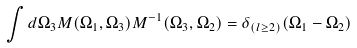Convert formula to latex. <formula><loc_0><loc_0><loc_500><loc_500>\int d \Omega _ { 3 } M ( \Omega _ { 1 } , \Omega _ { 3 } ) M ^ { - 1 } ( \Omega _ { 3 } , \Omega _ { 2 } ) = \delta _ { ( l \geq 2 ) } ( \Omega _ { 1 } - \Omega _ { 2 } )</formula> 